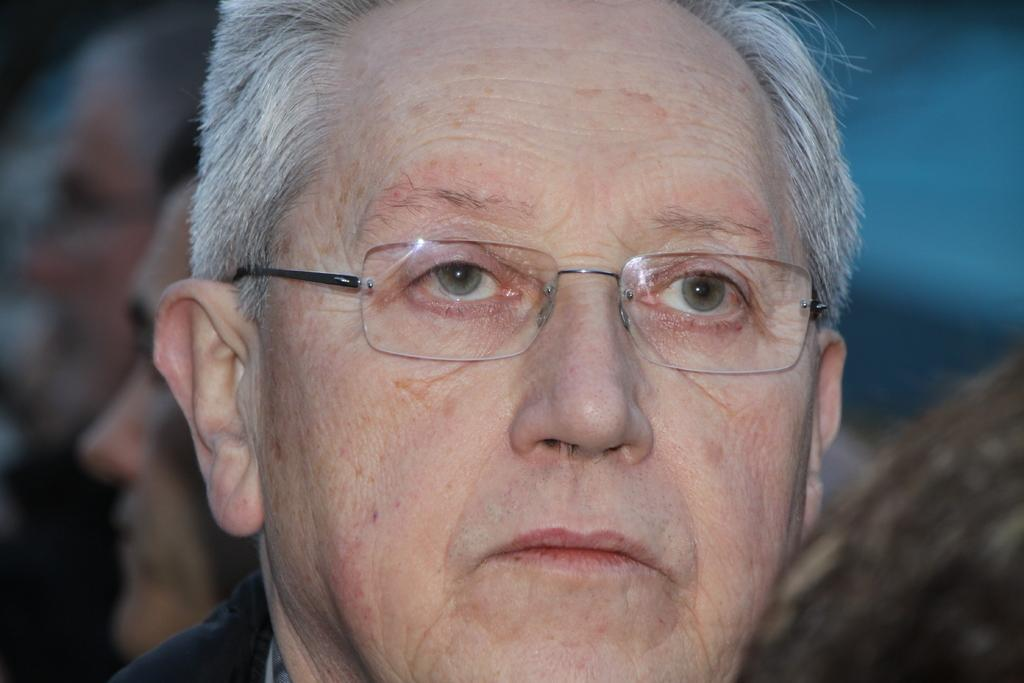What is the main subject of the image? There is a man in the image. What can be observed about the man's appearance? The man is wearing glasses (specs). Can you describe the people in the background of the image? The people in the background are blurry. What type of kettle is being used by the man in the image? There is no kettle present in the image. 